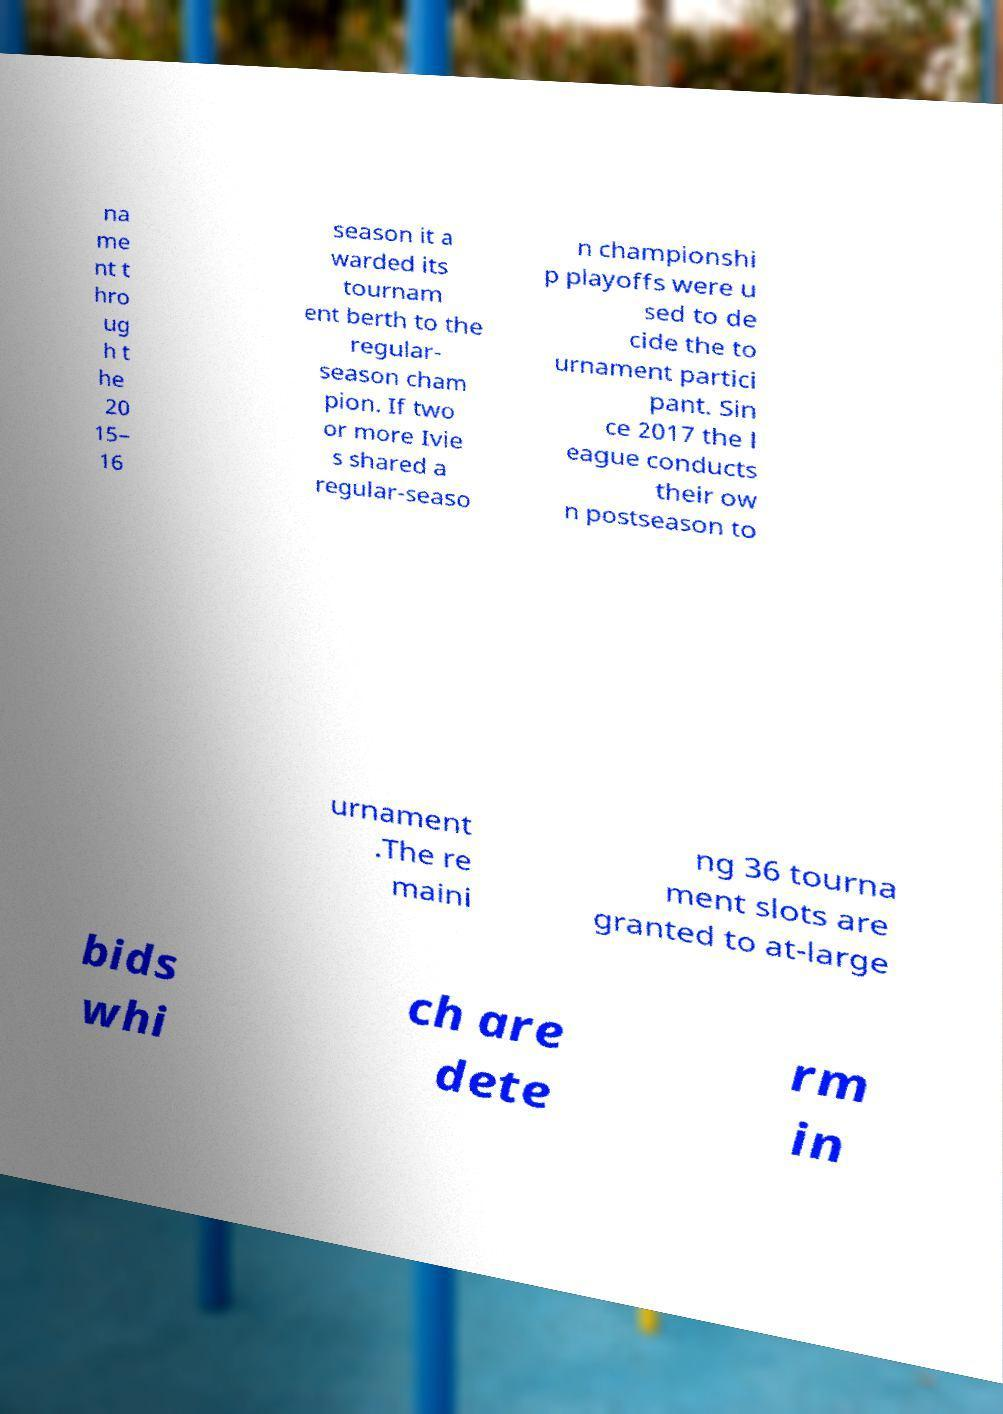Could you assist in decoding the text presented in this image and type it out clearly? na me nt t hro ug h t he 20 15– 16 season it a warded its tournam ent berth to the regular- season cham pion. If two or more Ivie s shared a regular-seaso n championshi p playoffs were u sed to de cide the to urnament partici pant. Sin ce 2017 the l eague conducts their ow n postseason to urnament .The re maini ng 36 tourna ment slots are granted to at-large bids whi ch are dete rm in 